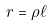Convert formula to latex. <formula><loc_0><loc_0><loc_500><loc_500>r = \rho \ell</formula> 